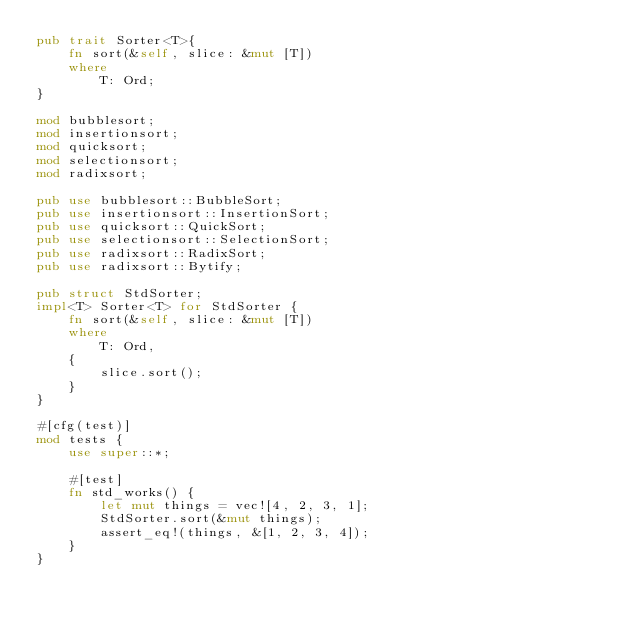<code> <loc_0><loc_0><loc_500><loc_500><_Rust_>pub trait Sorter<T>{
    fn sort(&self, slice: &mut [T])
    where
        T: Ord;
}

mod bubblesort;
mod insertionsort;
mod quicksort;
mod selectionsort;
mod radixsort;

pub use bubblesort::BubbleSort;
pub use insertionsort::InsertionSort;
pub use quicksort::QuickSort;
pub use selectionsort::SelectionSort;
pub use radixsort::RadixSort;
pub use radixsort::Bytify;

pub struct StdSorter;
impl<T> Sorter<T> for StdSorter {
    fn sort(&self, slice: &mut [T])
    where
        T: Ord,
    {
        slice.sort();
    }
}

#[cfg(test)]
mod tests {
    use super::*;

    #[test]
    fn std_works() {
        let mut things = vec![4, 2, 3, 1];
        StdSorter.sort(&mut things);
        assert_eq!(things, &[1, 2, 3, 4]);
    }
}
</code> 